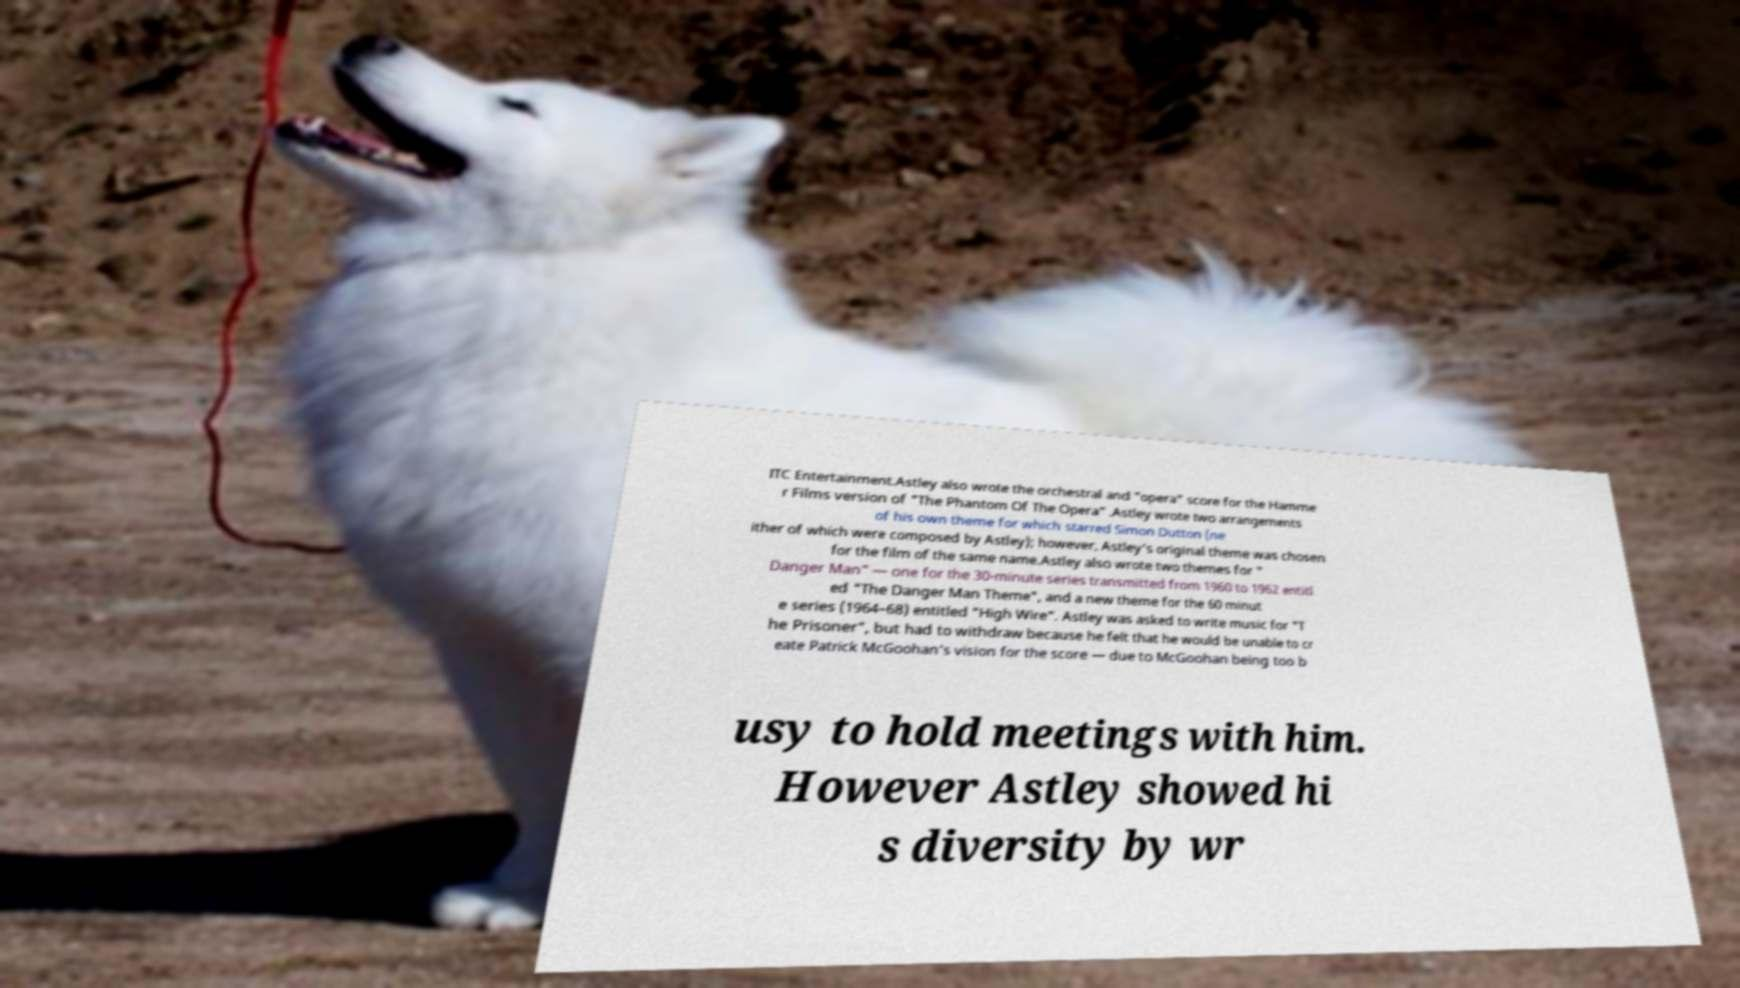There's text embedded in this image that I need extracted. Can you transcribe it verbatim? ITC Entertainment.Astley also wrote the orchestral and "opera" score for the Hamme r Films version of "The Phantom Of The Opera" .Astley wrote two arrangements of his own theme for which starred Simon Dutton (ne ither of which were composed by Astley); however, Astley's original theme was chosen for the film of the same name.Astley also wrote two themes for " Danger Man" — one for the 30-minute series transmitted from 1960 to 1962 entitl ed "The Danger Man Theme", and a new theme for the 60 minut e series (1964–68) entitled "High Wire". Astley was asked to write music for "T he Prisoner", but had to withdraw because he felt that he would be unable to cr eate Patrick McGoohan's vision for the score — due to McGoohan being too b usy to hold meetings with him. However Astley showed hi s diversity by wr 